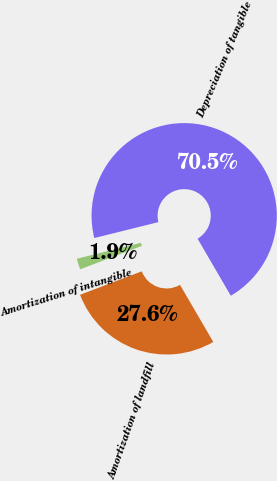<chart> <loc_0><loc_0><loc_500><loc_500><pie_chart><fcel>Depreciation of tangible<fcel>Amortization of landfill<fcel>Amortization of intangible<nl><fcel>70.48%<fcel>27.62%<fcel>1.9%<nl></chart> 